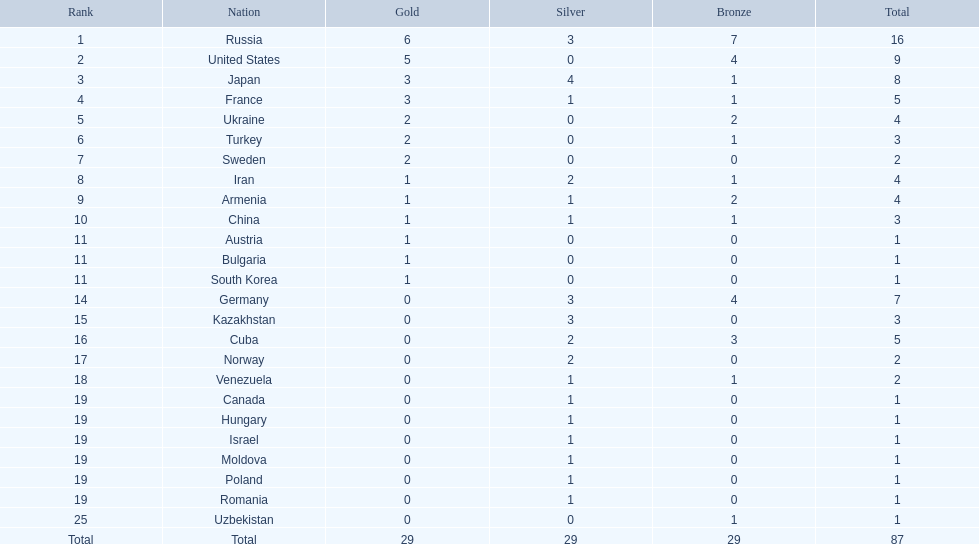How many countries were involved? Israel. How many cumulative medals did russia obtain? 16. Which country succeeded in winning only 1 medal? Uzbekistan. 